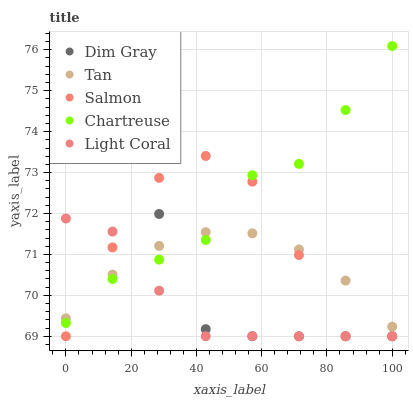Does Light Coral have the minimum area under the curve?
Answer yes or no. Yes. Does Chartreuse have the maximum area under the curve?
Answer yes or no. Yes. Does Tan have the minimum area under the curve?
Answer yes or no. No. Does Tan have the maximum area under the curve?
Answer yes or no. No. Is Tan the smoothest?
Answer yes or no. Yes. Is Salmon the roughest?
Answer yes or no. Yes. Is Dim Gray the smoothest?
Answer yes or no. No. Is Dim Gray the roughest?
Answer yes or no. No. Does Light Coral have the lowest value?
Answer yes or no. Yes. Does Tan have the lowest value?
Answer yes or no. No. Does Chartreuse have the highest value?
Answer yes or no. Yes. Does Dim Gray have the highest value?
Answer yes or no. No. Does Salmon intersect Dim Gray?
Answer yes or no. Yes. Is Salmon less than Dim Gray?
Answer yes or no. No. Is Salmon greater than Dim Gray?
Answer yes or no. No. 